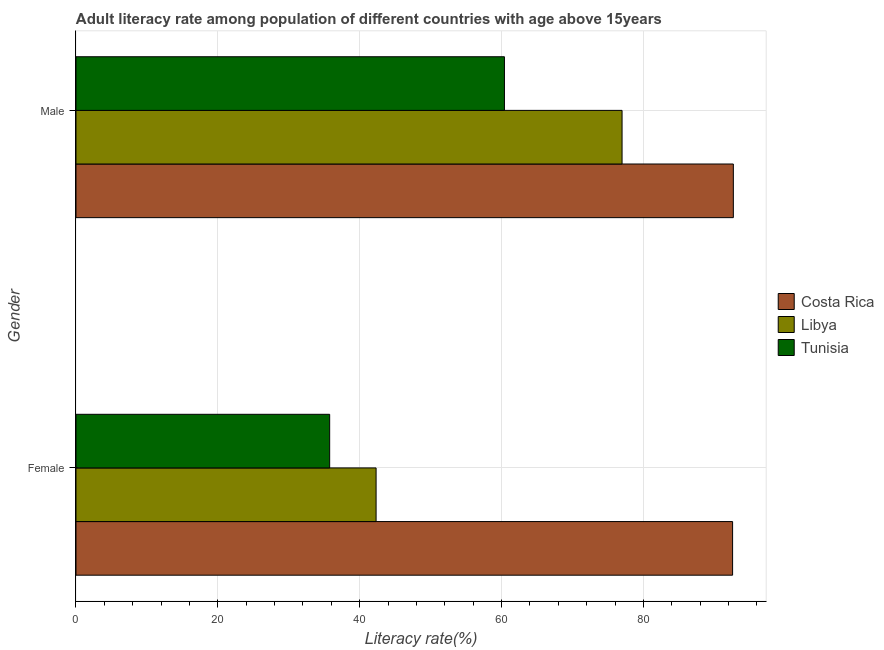Are the number of bars per tick equal to the number of legend labels?
Your answer should be compact. Yes. Are the number of bars on each tick of the Y-axis equal?
Your answer should be compact. Yes. How many bars are there on the 2nd tick from the bottom?
Provide a succinct answer. 3. What is the label of the 2nd group of bars from the top?
Provide a short and direct response. Female. What is the male adult literacy rate in Tunisia?
Your answer should be very brief. 60.41. Across all countries, what is the maximum female adult literacy rate?
Provide a succinct answer. 92.58. Across all countries, what is the minimum female adult literacy rate?
Keep it short and to the point. 35.77. In which country was the female adult literacy rate maximum?
Keep it short and to the point. Costa Rica. In which country was the female adult literacy rate minimum?
Give a very brief answer. Tunisia. What is the total female adult literacy rate in the graph?
Offer a very short reply. 170.66. What is the difference between the male adult literacy rate in Libya and that in Costa Rica?
Give a very brief answer. -15.69. What is the difference between the male adult literacy rate in Costa Rica and the female adult literacy rate in Libya?
Your response must be concise. 50.37. What is the average male adult literacy rate per country?
Offer a very short reply. 76.69. What is the difference between the male adult literacy rate and female adult literacy rate in Libya?
Keep it short and to the point. 34.68. What is the ratio of the female adult literacy rate in Libya to that in Costa Rica?
Provide a succinct answer. 0.46. Is the male adult literacy rate in Costa Rica less than that in Libya?
Your response must be concise. No. In how many countries, is the male adult literacy rate greater than the average male adult literacy rate taken over all countries?
Offer a terse response. 2. What does the 1st bar from the top in Female represents?
Offer a very short reply. Tunisia. What does the 2nd bar from the bottom in Male represents?
Your answer should be compact. Libya. Are all the bars in the graph horizontal?
Your answer should be very brief. Yes. Are the values on the major ticks of X-axis written in scientific E-notation?
Your answer should be very brief. No. Does the graph contain grids?
Provide a short and direct response. Yes. How many legend labels are there?
Your answer should be very brief. 3. What is the title of the graph?
Ensure brevity in your answer.  Adult literacy rate among population of different countries with age above 15years. What is the label or title of the X-axis?
Keep it short and to the point. Literacy rate(%). What is the Literacy rate(%) of Costa Rica in Female?
Give a very brief answer. 92.58. What is the Literacy rate(%) of Libya in Female?
Your answer should be compact. 42.31. What is the Literacy rate(%) in Tunisia in Female?
Your answer should be very brief. 35.77. What is the Literacy rate(%) in Costa Rica in Male?
Provide a short and direct response. 92.68. What is the Literacy rate(%) of Libya in Male?
Keep it short and to the point. 76.99. What is the Literacy rate(%) in Tunisia in Male?
Offer a terse response. 60.41. Across all Gender, what is the maximum Literacy rate(%) in Costa Rica?
Give a very brief answer. 92.68. Across all Gender, what is the maximum Literacy rate(%) in Libya?
Your answer should be very brief. 76.99. Across all Gender, what is the maximum Literacy rate(%) in Tunisia?
Provide a short and direct response. 60.41. Across all Gender, what is the minimum Literacy rate(%) of Costa Rica?
Keep it short and to the point. 92.58. Across all Gender, what is the minimum Literacy rate(%) in Libya?
Ensure brevity in your answer.  42.31. Across all Gender, what is the minimum Literacy rate(%) in Tunisia?
Give a very brief answer. 35.77. What is the total Literacy rate(%) in Costa Rica in the graph?
Your answer should be compact. 185.26. What is the total Literacy rate(%) of Libya in the graph?
Your answer should be very brief. 119.31. What is the total Literacy rate(%) of Tunisia in the graph?
Make the answer very short. 96.17. What is the difference between the Literacy rate(%) of Costa Rica in Female and that in Male?
Keep it short and to the point. -0.1. What is the difference between the Literacy rate(%) in Libya in Female and that in Male?
Provide a succinct answer. -34.68. What is the difference between the Literacy rate(%) of Tunisia in Female and that in Male?
Ensure brevity in your answer.  -24.64. What is the difference between the Literacy rate(%) of Costa Rica in Female and the Literacy rate(%) of Libya in Male?
Offer a very short reply. 15.58. What is the difference between the Literacy rate(%) of Costa Rica in Female and the Literacy rate(%) of Tunisia in Male?
Ensure brevity in your answer.  32.17. What is the difference between the Literacy rate(%) of Libya in Female and the Literacy rate(%) of Tunisia in Male?
Offer a very short reply. -18.09. What is the average Literacy rate(%) of Costa Rica per Gender?
Your answer should be compact. 92.63. What is the average Literacy rate(%) of Libya per Gender?
Your answer should be compact. 59.65. What is the average Literacy rate(%) of Tunisia per Gender?
Provide a short and direct response. 48.09. What is the difference between the Literacy rate(%) in Costa Rica and Literacy rate(%) in Libya in Female?
Provide a short and direct response. 50.26. What is the difference between the Literacy rate(%) in Costa Rica and Literacy rate(%) in Tunisia in Female?
Offer a terse response. 56.81. What is the difference between the Literacy rate(%) of Libya and Literacy rate(%) of Tunisia in Female?
Ensure brevity in your answer.  6.55. What is the difference between the Literacy rate(%) in Costa Rica and Literacy rate(%) in Libya in Male?
Give a very brief answer. 15.69. What is the difference between the Literacy rate(%) of Costa Rica and Literacy rate(%) of Tunisia in Male?
Your answer should be compact. 32.27. What is the difference between the Literacy rate(%) of Libya and Literacy rate(%) of Tunisia in Male?
Your answer should be compact. 16.59. What is the ratio of the Literacy rate(%) in Costa Rica in Female to that in Male?
Offer a very short reply. 1. What is the ratio of the Literacy rate(%) in Libya in Female to that in Male?
Your answer should be compact. 0.55. What is the ratio of the Literacy rate(%) in Tunisia in Female to that in Male?
Your response must be concise. 0.59. What is the difference between the highest and the second highest Literacy rate(%) of Costa Rica?
Give a very brief answer. 0.1. What is the difference between the highest and the second highest Literacy rate(%) of Libya?
Offer a very short reply. 34.68. What is the difference between the highest and the second highest Literacy rate(%) of Tunisia?
Your answer should be compact. 24.64. What is the difference between the highest and the lowest Literacy rate(%) in Costa Rica?
Provide a succinct answer. 0.1. What is the difference between the highest and the lowest Literacy rate(%) of Libya?
Offer a very short reply. 34.68. What is the difference between the highest and the lowest Literacy rate(%) of Tunisia?
Ensure brevity in your answer.  24.64. 